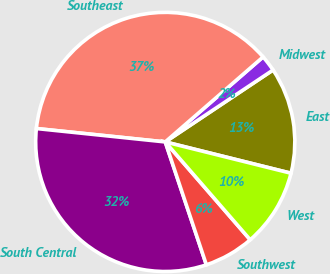<chart> <loc_0><loc_0><loc_500><loc_500><pie_chart><fcel>East<fcel>Midwest<fcel>Southeast<fcel>South Central<fcel>Southwest<fcel>West<nl><fcel>13.25%<fcel>2.02%<fcel>36.97%<fcel>31.79%<fcel>6.24%<fcel>9.74%<nl></chart> 